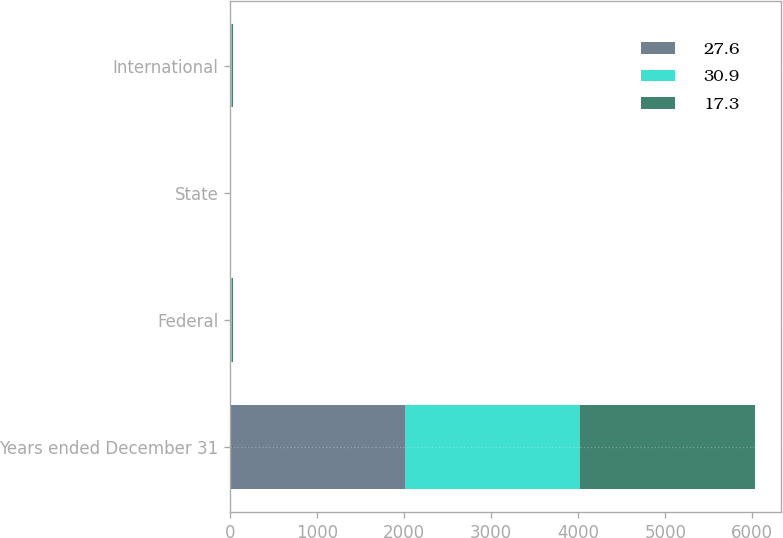Convert chart. <chart><loc_0><loc_0><loc_500><loc_500><stacked_bar_chart><ecel><fcel>Years ended December 31<fcel>Federal<fcel>State<fcel>International<nl><fcel>27.6<fcel>2010<fcel>2.9<fcel>2.4<fcel>14.1<nl><fcel>30.9<fcel>2009<fcel>16<fcel>2.9<fcel>12.9<nl><fcel>17.3<fcel>2008<fcel>11.7<fcel>2.9<fcel>10.1<nl></chart> 